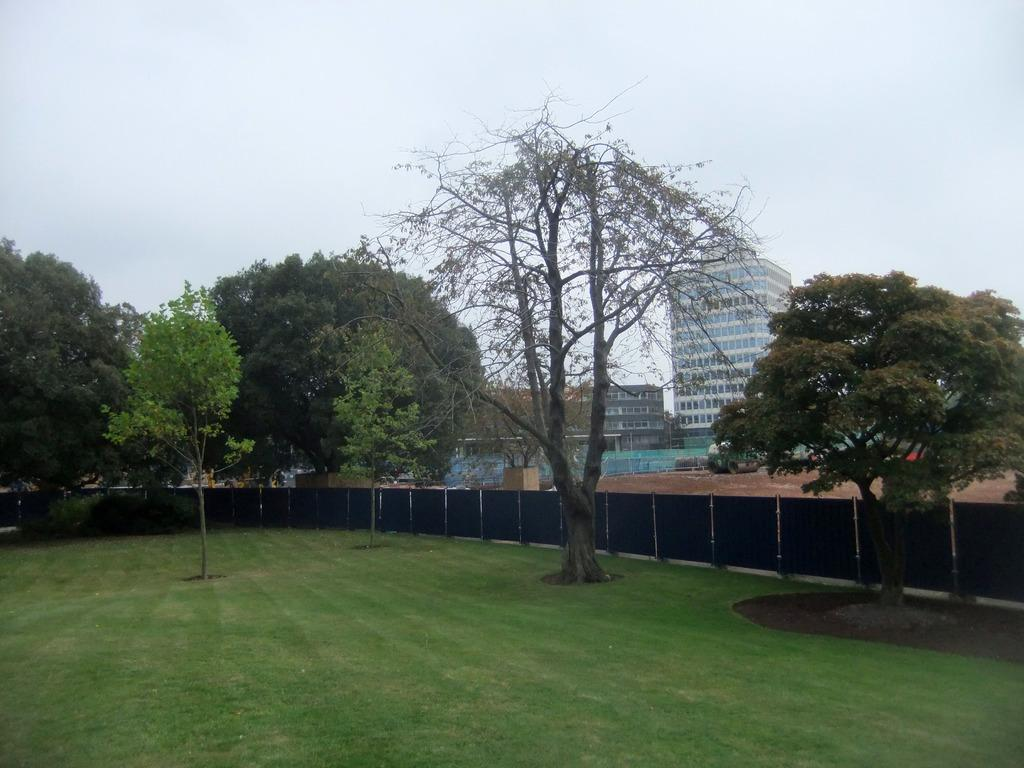What type of ground surface is visible in the image? There is green grass on the ground in the image. What can be seen in the distance behind the grass? There are many trees and buildings in the background of the image. What is visible at the top of the image? The sky is visible at the top of the image. How many times does the mom appear in the image? There is no mom present in the image. What type of animal is the donkey in the image? There is no donkey present in the image. 